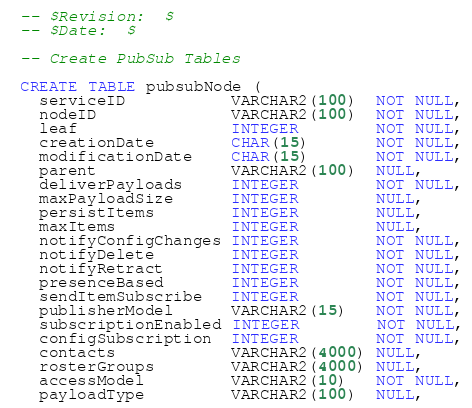Convert code to text. <code><loc_0><loc_0><loc_500><loc_500><_SQL_>-- $Revision:  $
-- $Date:  $

-- Create PubSub Tables

CREATE TABLE pubsubNode (
  serviceID           VARCHAR2(100)  NOT NULL,
  nodeID              VARCHAR2(100)  NOT NULL,
  leaf                INTEGER        NOT NULL,
  creationDate        CHAR(15)       NOT NULL,
  modificationDate    CHAR(15)       NOT NULL,
  parent              VARCHAR2(100)  NULL,
  deliverPayloads     INTEGER        NOT NULL,
  maxPayloadSize      INTEGER        NULL,
  persistItems        INTEGER        NULL,
  maxItems            INTEGER        NULL,
  notifyConfigChanges INTEGER        NOT NULL,
  notifyDelete        INTEGER        NOT NULL,
  notifyRetract       INTEGER        NOT NULL,
  presenceBased       INTEGER        NOT NULL,
  sendItemSubscribe   INTEGER        NOT NULL,
  publisherModel      VARCHAR2(15)   NOT NULL,
  subscriptionEnabled INTEGER        NOT NULL,
  configSubscription  INTEGER        NOT NULL,
  contacts            VARCHAR2(4000) NULL,
  rosterGroups        VARCHAR2(4000) NULL,
  accessModel         VARCHAR2(10)   NOT NULL,
  payloadType         VARCHAR2(100)  NULL,</code> 